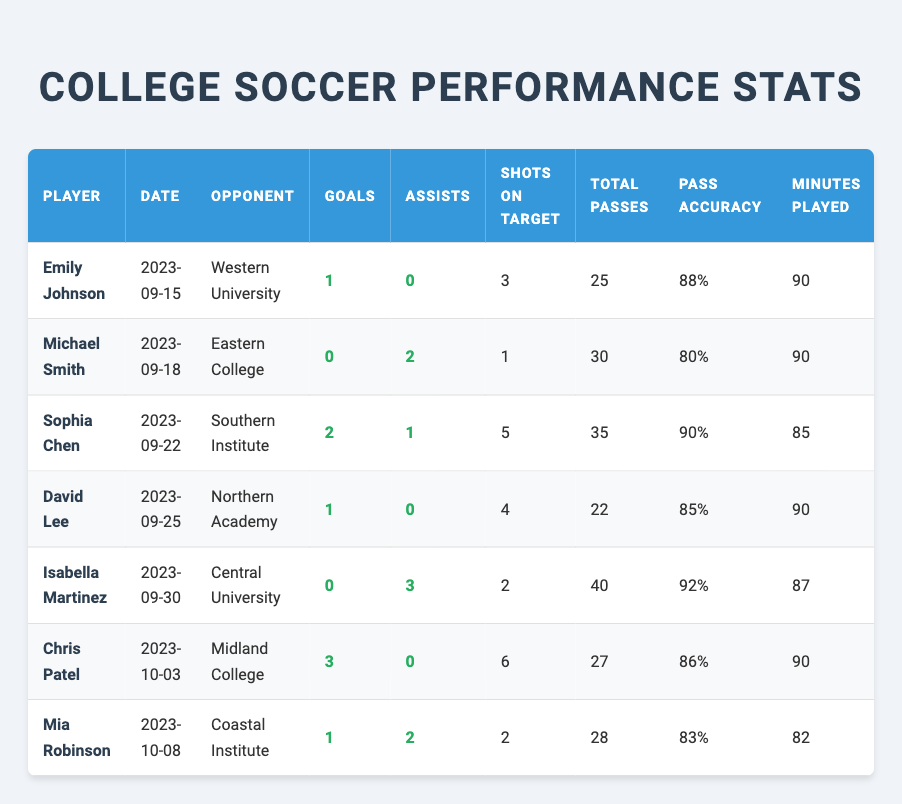What player scored the most goals in a single match? Chris Patel scored 3 goals against Midland College on October 3, 2023. This information can be found in the "Goals" column of the table.
Answer: Chris Patel How many assists did Isabella Martinez have in her match against Central University? Isabella Martinez had 3 assists in her match on September 30, 2023. This is shown in the "Assists" column of the table.
Answer: 3 What is the total number of goals scored by all players in the provided matches? To find the total goals, sum the goals scored by each player: 1 (Emily) + 0 (Michael) + 2 (Sophia) + 1 (David) + 0 (Isabella) + 3 (Chris) + 1 (Mia) = 8.
Answer: 8 Did any player receive a red card in their matches? According to the "Cards" column, no player received a red card, as all entries show either no cards or yellow cards.
Answer: No Who had the highest pass accuracy and what was it? Sophia Chen had the highest pass accuracy at 90%, as listed in the "Pass Accuracy" column.
Answer: 90% What is the average number of minutes played across all matches? The total minutes played are 90 + 90 + 85 + 90 + 87 + 90 + 82 = 514. With 7 players, the average is 514 / 7 = 73.43.
Answer: 73.43 Which player had the fewest shots on target in their match? Michael Smith had the fewest shots on target with 1 against Eastern College on September 18, 2023, as noted in the "Shots on Target" column.
Answer: Michael Smith How many yellow cards were accumulated in total by all players? The total yellow cards are 0 (Emily) + 1 (Michael) + 0 (Sophia) + 2 (David) + 0 (Isabella) + 0 (Chris) + 1 (Mia) = 4.
Answer: 4 Which match had the highest total passes made by a single player? Isabella Martinez had the highest total passes with 40 in her match against Central University on September 30, 2023, as indicated in the "Total Passes" column.
Answer: Isabella Martinez What percentage of total passes did Chris Patel complete? Chris Patel's pass accuracy is 86%, indicating he completed 86% of his 27 total passes. The calculation involves taking the percentage directly from the "Pass Accuracy" column.
Answer: 86% 